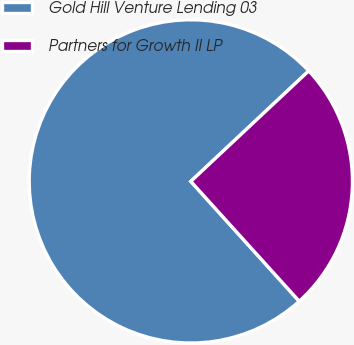<chart> <loc_0><loc_0><loc_500><loc_500><pie_chart><fcel>Gold Hill Venture Lending 03<fcel>Partners for Growth II LP<nl><fcel>74.72%<fcel>25.28%<nl></chart> 